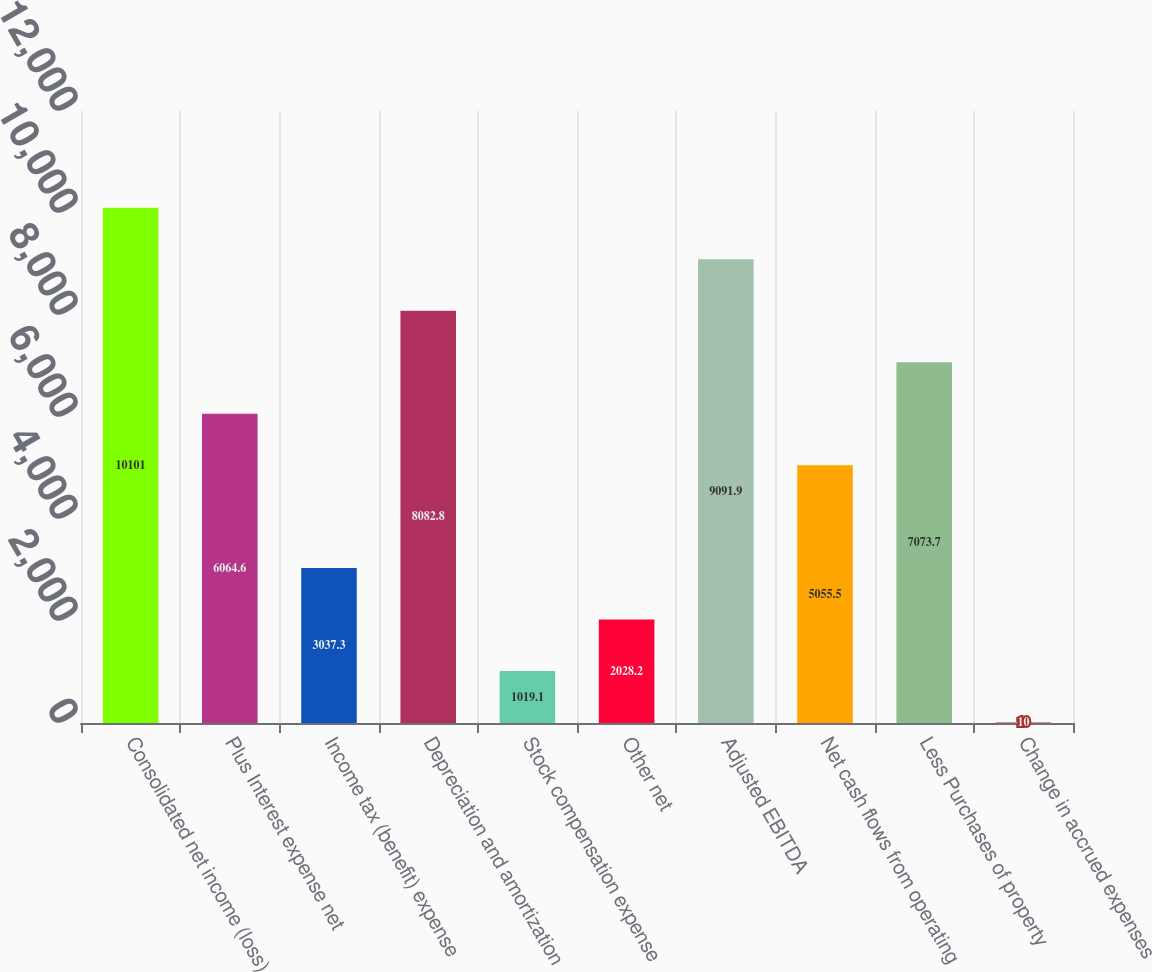Convert chart. <chart><loc_0><loc_0><loc_500><loc_500><bar_chart><fcel>Consolidated net income (loss)<fcel>Plus Interest expense net<fcel>Income tax (benefit) expense<fcel>Depreciation and amortization<fcel>Stock compensation expense<fcel>Other net<fcel>Adjusted EBITDA<fcel>Net cash flows from operating<fcel>Less Purchases of property<fcel>Change in accrued expenses<nl><fcel>10101<fcel>6064.6<fcel>3037.3<fcel>8082.8<fcel>1019.1<fcel>2028.2<fcel>9091.9<fcel>5055.5<fcel>7073.7<fcel>10<nl></chart> 